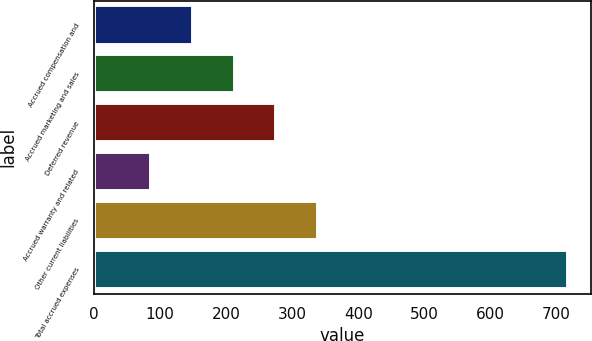<chart> <loc_0><loc_0><loc_500><loc_500><bar_chart><fcel>Accrued compensation and<fcel>Accrued marketing and sales<fcel>Deferred revenue<fcel>Accrued warranty and related<fcel>Other current liabilities<fcel>Total accrued expenses<nl><fcel>150<fcel>213<fcel>276<fcel>87<fcel>339<fcel>717<nl></chart> 